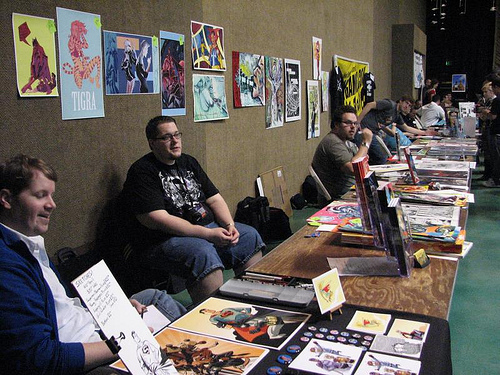<image>
Is the man behind the man? No. The man is not behind the man. From this viewpoint, the man appears to be positioned elsewhere in the scene. 